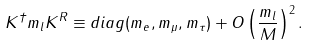Convert formula to latex. <formula><loc_0><loc_0><loc_500><loc_500>K ^ { \dagger } m _ { l } K ^ { R } \equiv d i a g ( m _ { e } , m _ { \mu } , m _ { \tau } ) + O \left ( \frac { m _ { l } } { M } \right ) ^ { 2 } .</formula> 